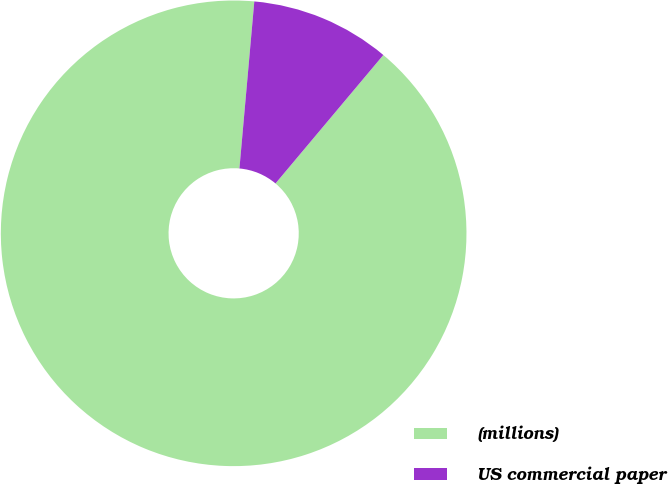Convert chart. <chart><loc_0><loc_0><loc_500><loc_500><pie_chart><fcel>(millions)<fcel>US commercial paper<nl><fcel>90.3%<fcel>9.7%<nl></chart> 